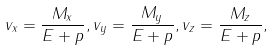<formula> <loc_0><loc_0><loc_500><loc_500>v _ { x } = \frac { M _ { x } } { E + p } , v _ { y } = \frac { M _ { y } } { E + p } , v _ { z } = \frac { M _ { z } } { E + p } ,</formula> 